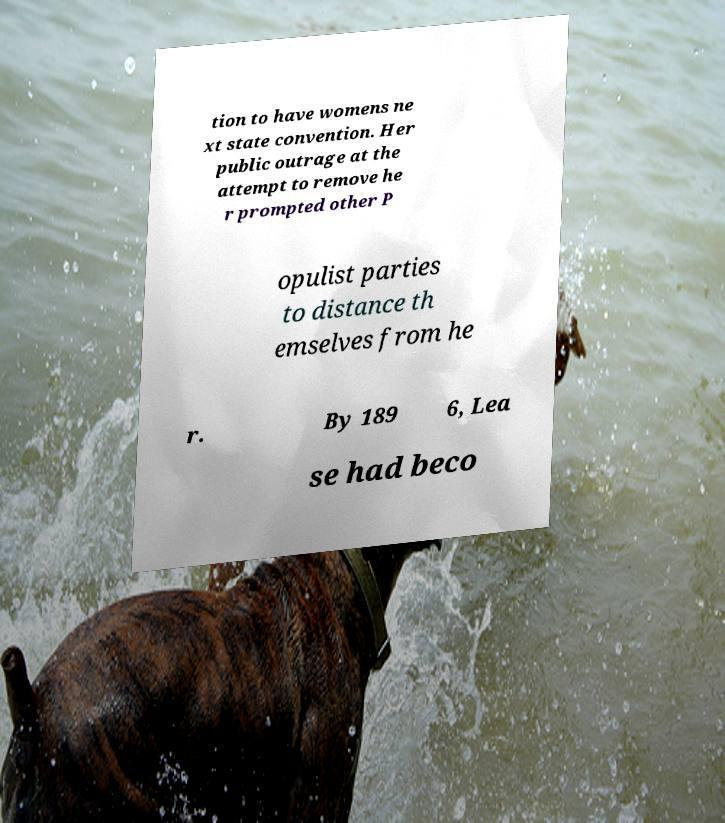There's text embedded in this image that I need extracted. Can you transcribe it verbatim? tion to have womens ne xt state convention. Her public outrage at the attempt to remove he r prompted other P opulist parties to distance th emselves from he r. By 189 6, Lea se had beco 